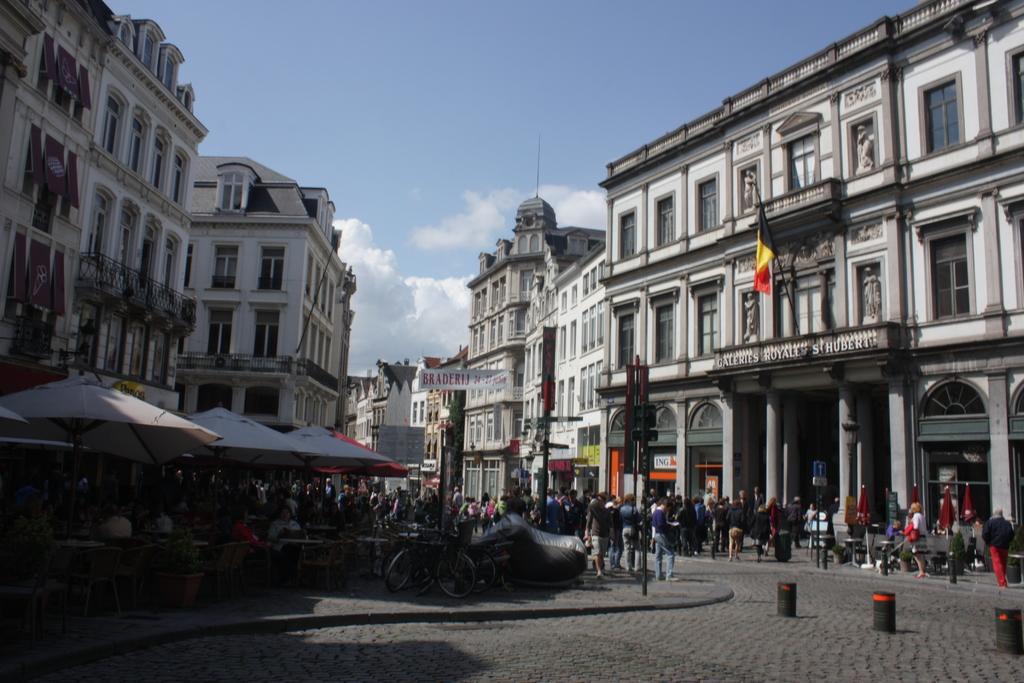Could you give a brief overview of what you see in this image? In this image we can see persons standing on the road and some are sitting on the benches, barrier poles, flag to the flag post, advertisements, buildings, parasols, statues, railings and sky with clouds. 